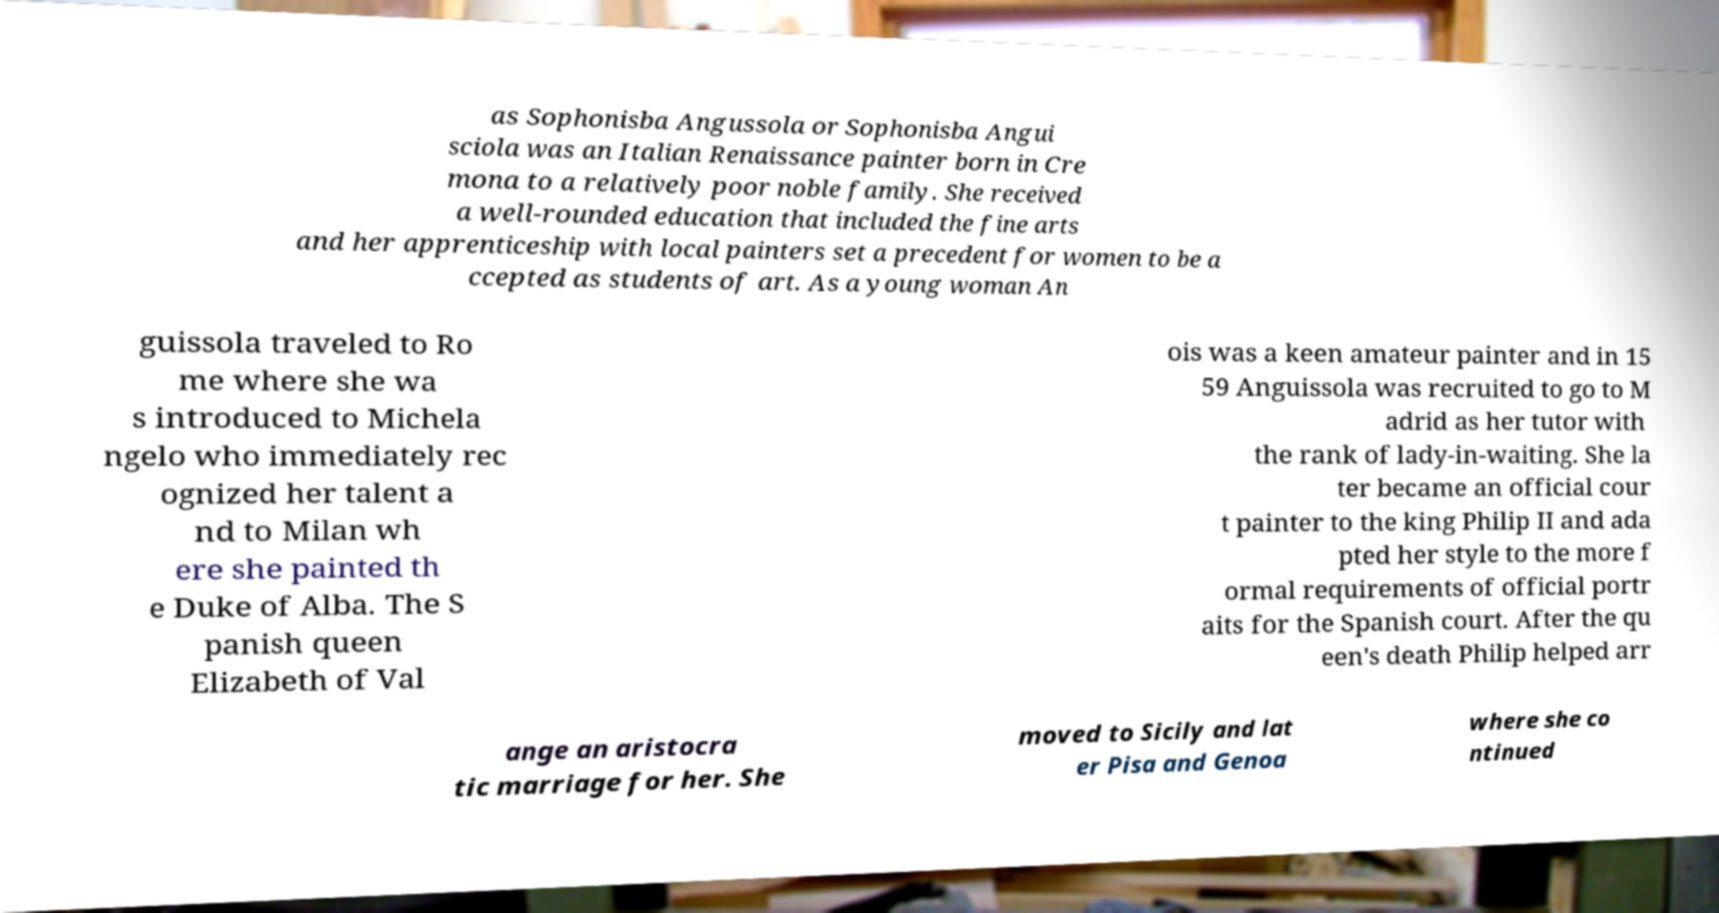Can you accurately transcribe the text from the provided image for me? as Sophonisba Angussola or Sophonisba Angui sciola was an Italian Renaissance painter born in Cre mona to a relatively poor noble family. She received a well-rounded education that included the fine arts and her apprenticeship with local painters set a precedent for women to be a ccepted as students of art. As a young woman An guissola traveled to Ro me where she wa s introduced to Michela ngelo who immediately rec ognized her talent a nd to Milan wh ere she painted th e Duke of Alba. The S panish queen Elizabeth of Val ois was a keen amateur painter and in 15 59 Anguissola was recruited to go to M adrid as her tutor with the rank of lady-in-waiting. She la ter became an official cour t painter to the king Philip II and ada pted her style to the more f ormal requirements of official portr aits for the Spanish court. After the qu een's death Philip helped arr ange an aristocra tic marriage for her. She moved to Sicily and lat er Pisa and Genoa where she co ntinued 